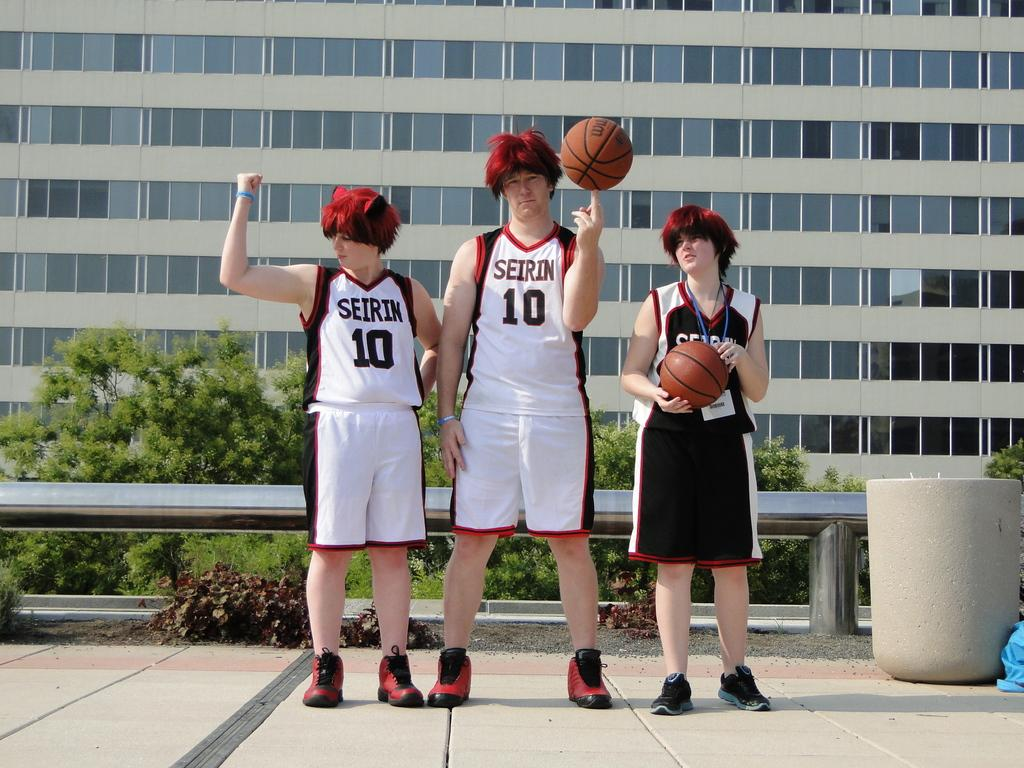<image>
Relay a brief, clear account of the picture shown. Three basketball players wearing Seirin jerseys stand with basketballs and red wigs. 